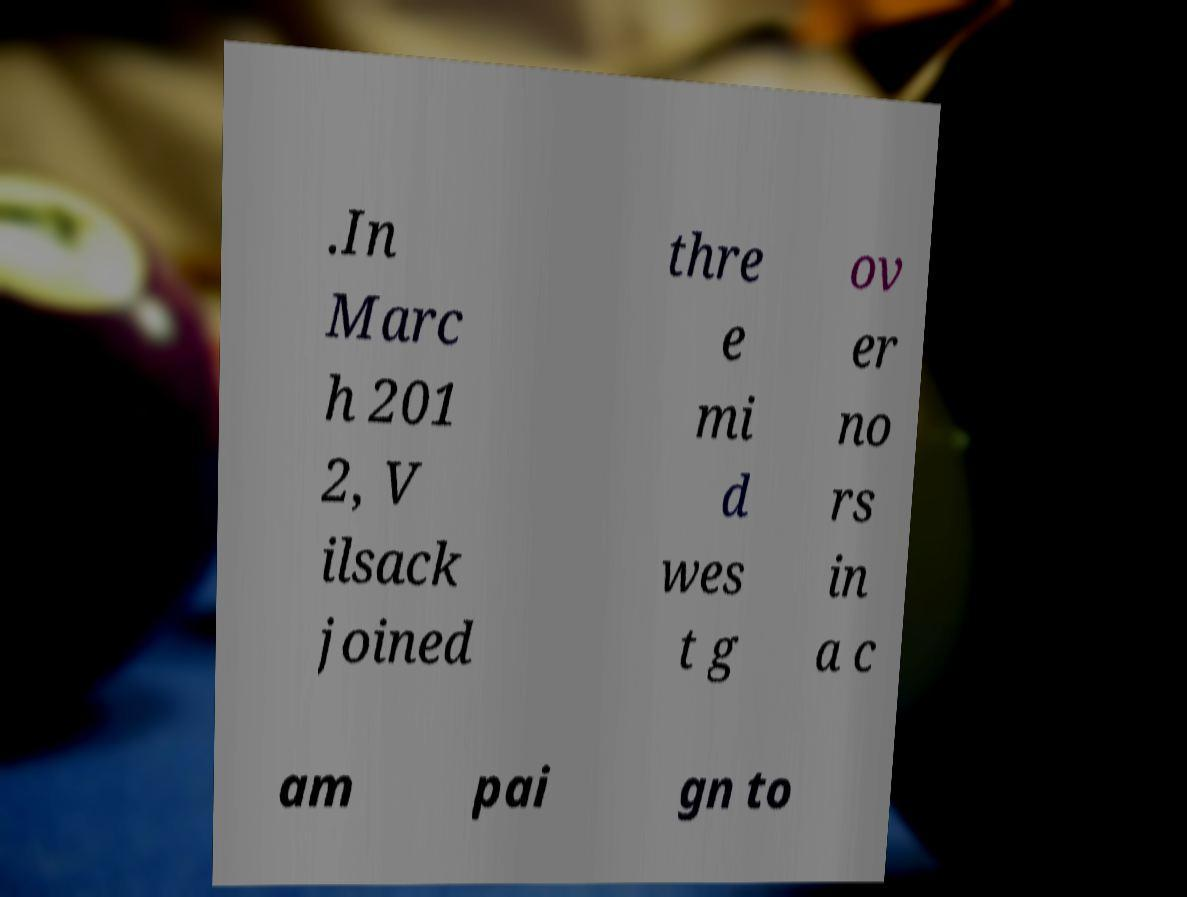Please read and relay the text visible in this image. What does it say? .In Marc h 201 2, V ilsack joined thre e mi d wes t g ov er no rs in a c am pai gn to 